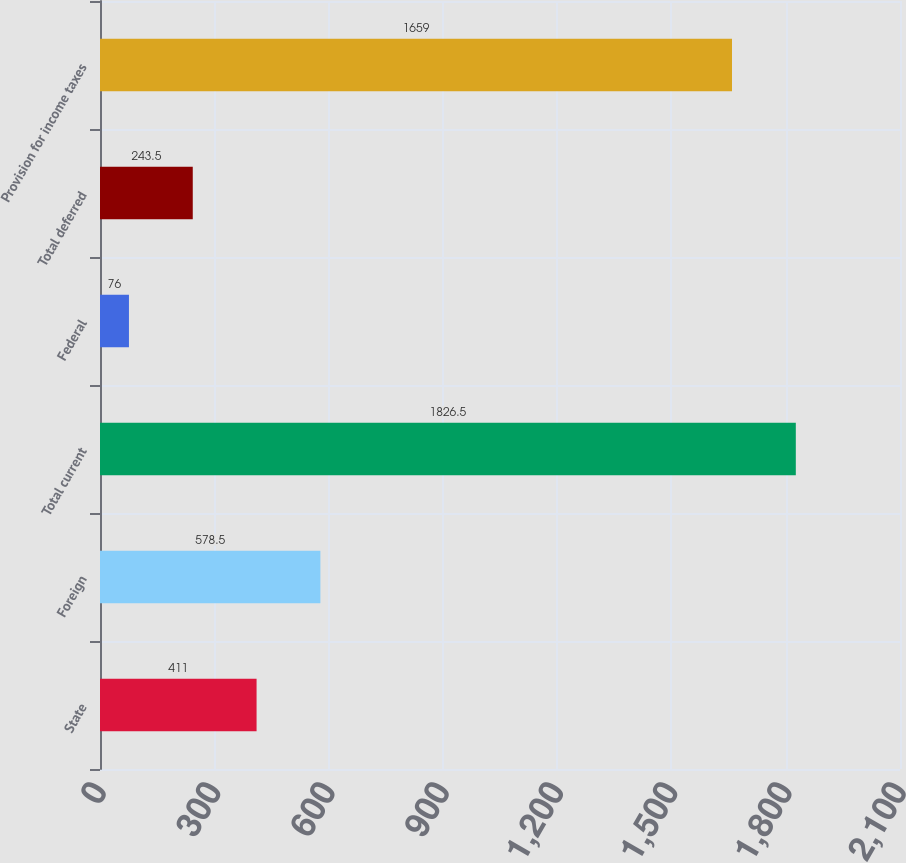Convert chart to OTSL. <chart><loc_0><loc_0><loc_500><loc_500><bar_chart><fcel>State<fcel>Foreign<fcel>Total current<fcel>Federal<fcel>Total deferred<fcel>Provision for income taxes<nl><fcel>411<fcel>578.5<fcel>1826.5<fcel>76<fcel>243.5<fcel>1659<nl></chart> 